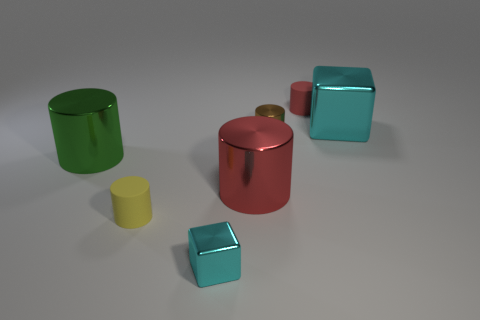Subtract all metal cylinders. How many cylinders are left? 2 Subtract 2 cylinders. How many cylinders are left? 3 Add 2 big metallic cubes. How many objects exist? 9 Subtract all purple cubes. How many green cylinders are left? 1 Subtract all green cylinders. How many cylinders are left? 4 Subtract 0 blue spheres. How many objects are left? 7 Subtract all cubes. How many objects are left? 5 Subtract all green cylinders. Subtract all purple blocks. How many cylinders are left? 4 Subtract all small yellow things. Subtract all big metallic cubes. How many objects are left? 5 Add 2 large metallic objects. How many large metallic objects are left? 5 